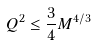Convert formula to latex. <formula><loc_0><loc_0><loc_500><loc_500>Q ^ { 2 } \leq \frac { 3 } { 4 } M ^ { 4 / 3 }</formula> 